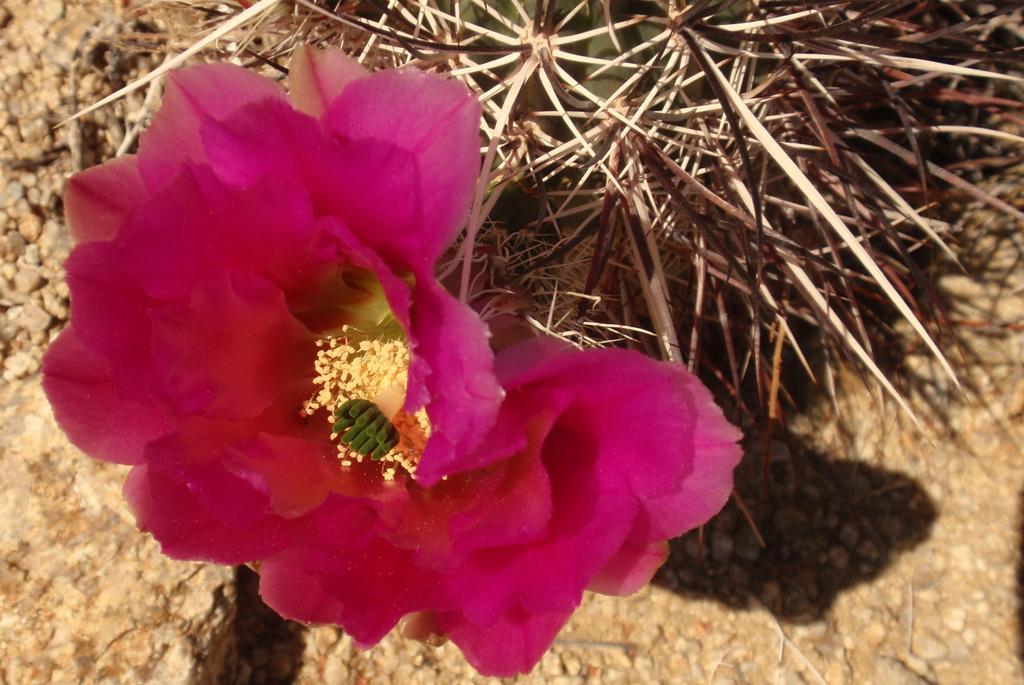Can you describe this image briefly? In the foreground of the picture there is a flower in pink color. At the top there are thorns of a tree. At the bottom it is soil. 